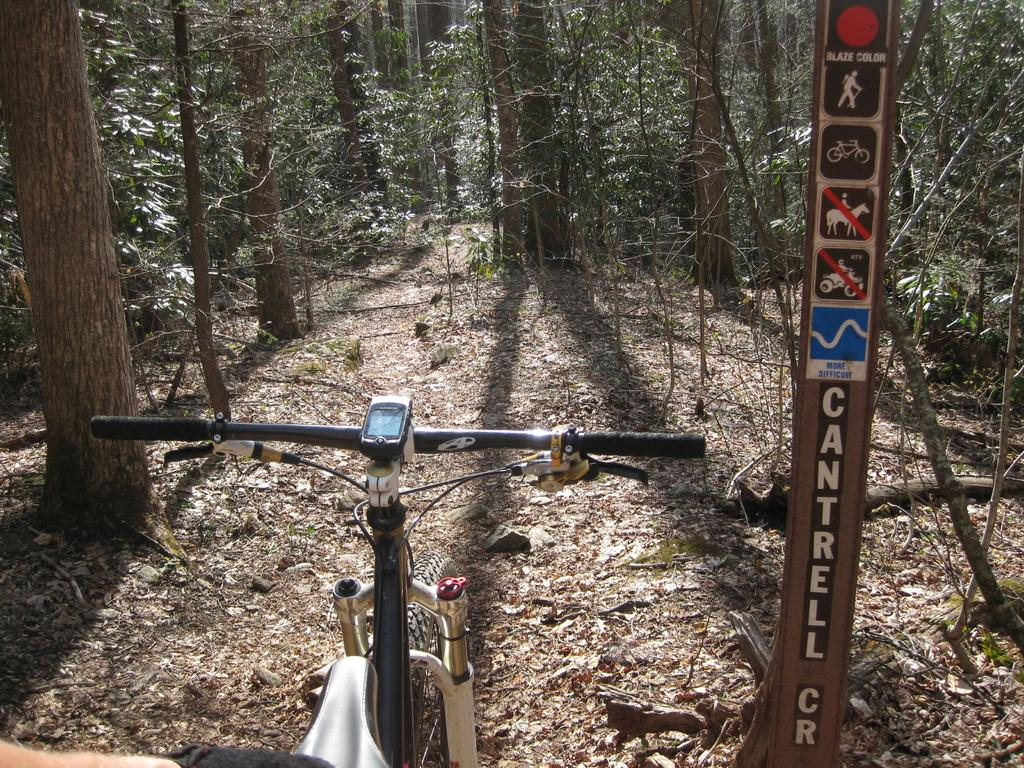What is the main object in the image? There is a bicycle in the image. What else can be seen on the right side of the image? There are stickers on an iron pole on the right side of the image. What type of natural elements are visible in the image? Trees are visible in the image. What is present on the ground in the image? Dried leaves are present on the ground in the image. What type of dirt can be seen in the image? There is no dirt visible in the image; it only shows a bicycle, stickers on an iron pole, trees, and dried leaves on the ground. 